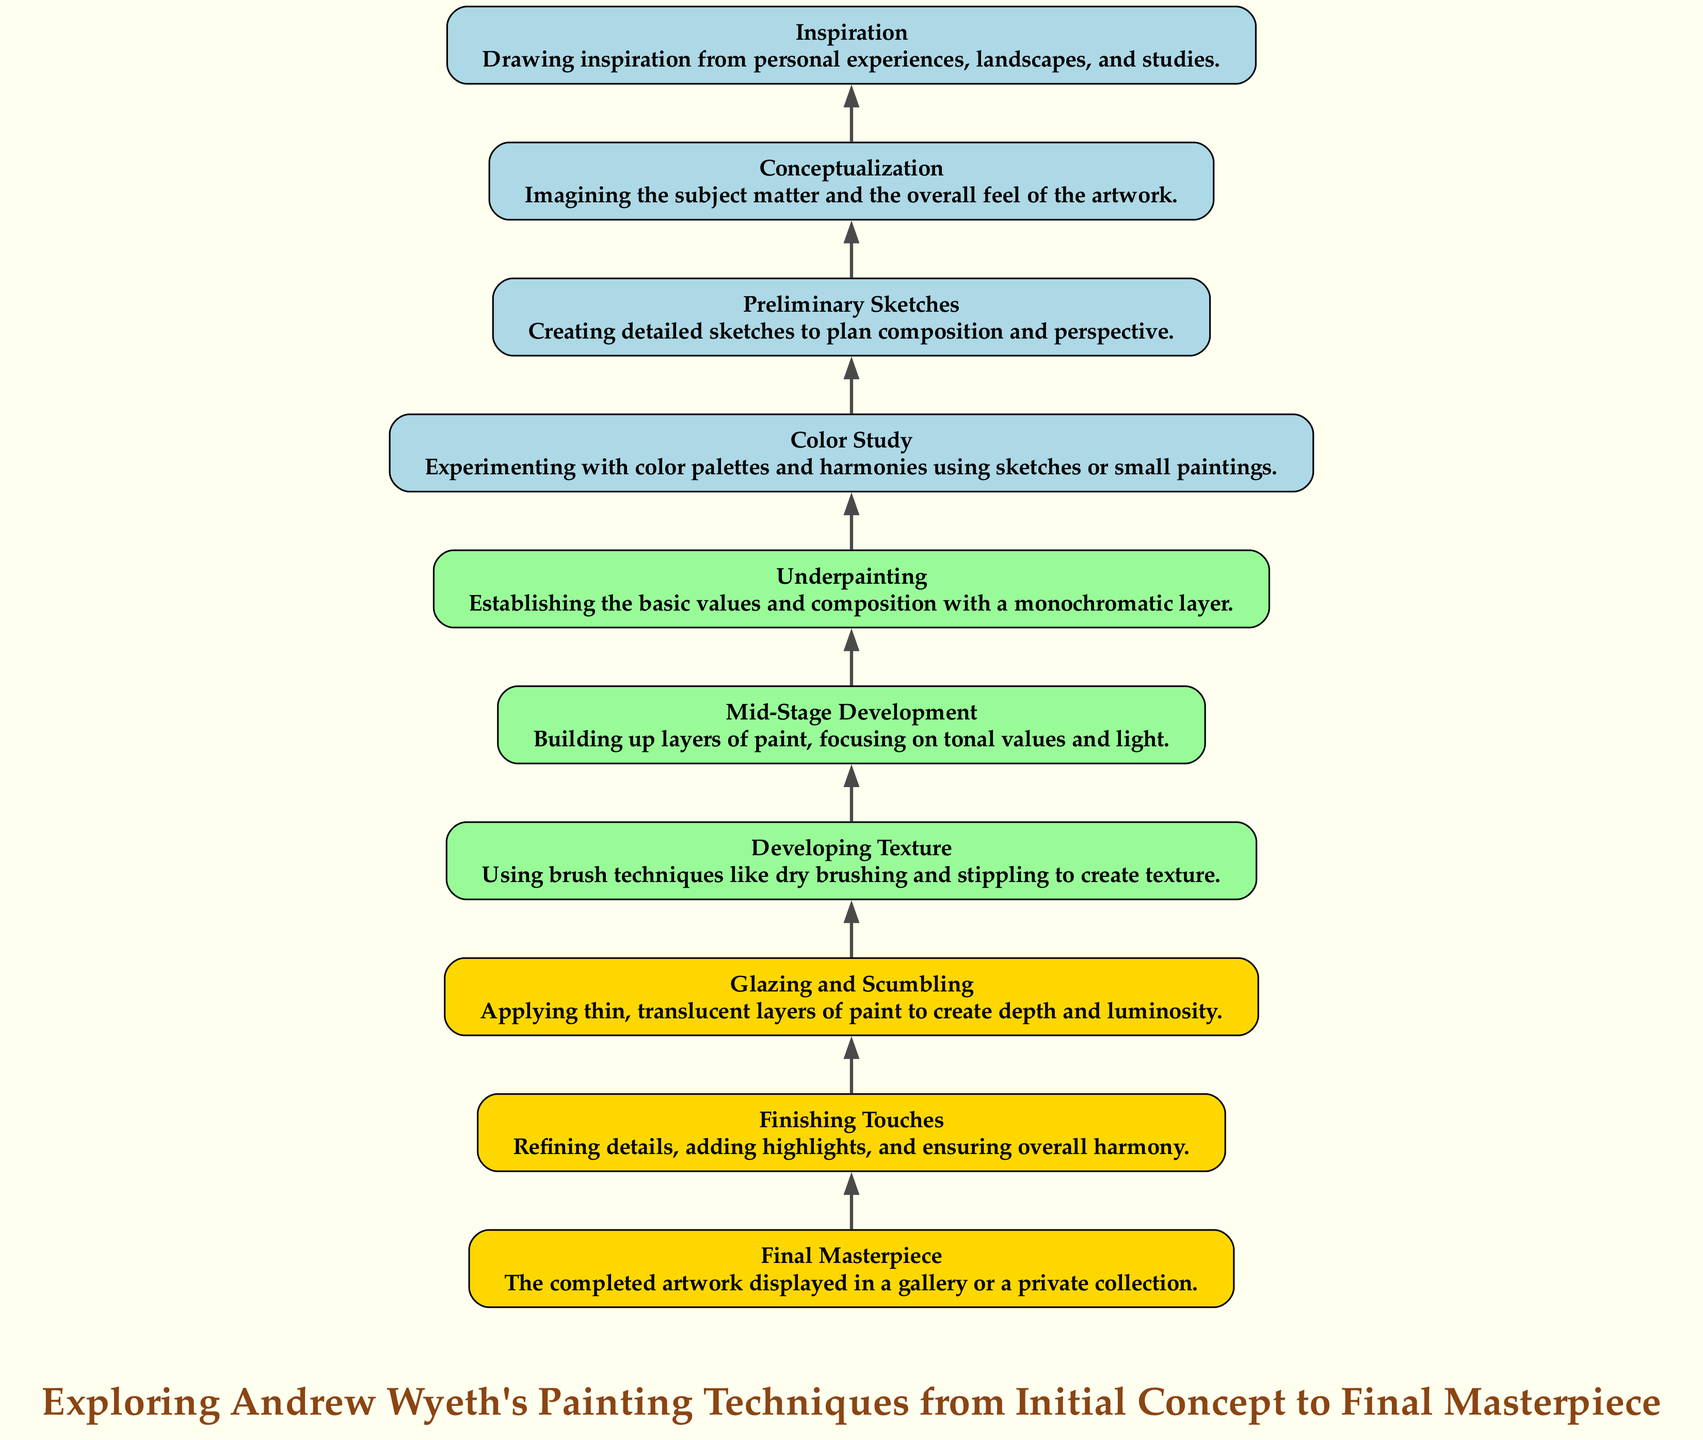What is the final node in the diagram? The diagram's final node displays "Final Masterpiece," indicating the completed artwork as the end result of the painting process.
Answer: Final Masterpiece How many levels are represented in the diagram? The diagram consists of ten distinct levels, from Initial Concept to Final Masterpiece.
Answer: Ten What stage comes before "Finishing Touches"? "Glazing and Scumbling" is the step that precedes "Finishing Touches," showing the progression in painting techniques.
Answer: Glazing and Scumbling Which level involves creating detailed sketches? The "Preliminary Sketches" level focuses on creating detailed sketches for planning. This is one of the initial steps in the process.
Answer: Preliminary Sketches In terms of painting techniques, what is primarily focused on in "Developing Texture"? "Developing Texture" emphasizes using brush techniques like dry brushing and stippling to enhance the texture of the painting.
Answer: Brush techniques What is the initial stage of the painting process in the diagram? The diagram starts with "Inspiration," which draws from personal experiences and landscapes to spark the creative process.
Answer: Inspiration How does "Color Study" relate to "Conceptualization" in the diagram? "Color Study," which involves experimenting with color palettes, follows "Conceptualization," where the overall feel of the artwork is imagined, showing a progression from ideas to color decisions.
Answer: It follows What is the primary aim of "Underpainting"? The goal of "Underpainting" is to establish the basic values and composition, serving as a foundation for the subsequent painting layers.
Answer: Establishing values Which two steps focus on layering paint? Both "Mid-Stage Development" and "Glazing and Scumbling" focus on the application of layers, with the former building up tonal values and the latter applying translucent layers.
Answer: Mid-Stage Development and Glazing and Scumbling 